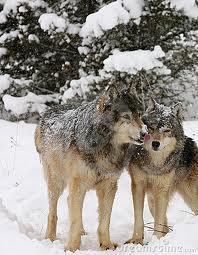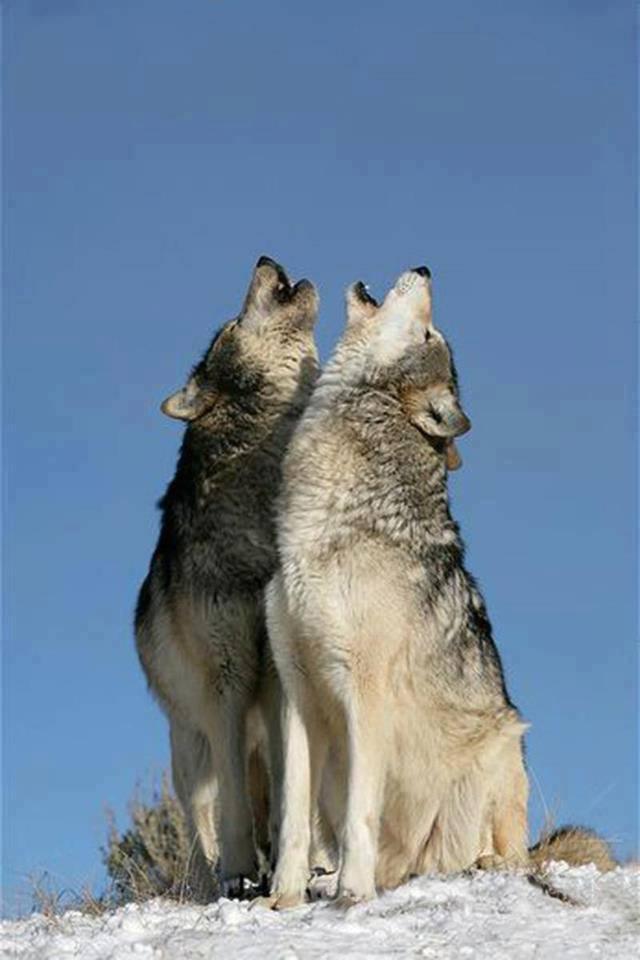The first image is the image on the left, the second image is the image on the right. For the images displayed, is the sentence "There are two wolves in each image." factually correct? Answer yes or no. Yes. The first image is the image on the left, the second image is the image on the right. For the images displayed, is the sentence "The combined images contain four wolves, including two adult wolves sitting upright with heads lifted, eyes shut, and mouths open in a howling pose." factually correct? Answer yes or no. Yes. 